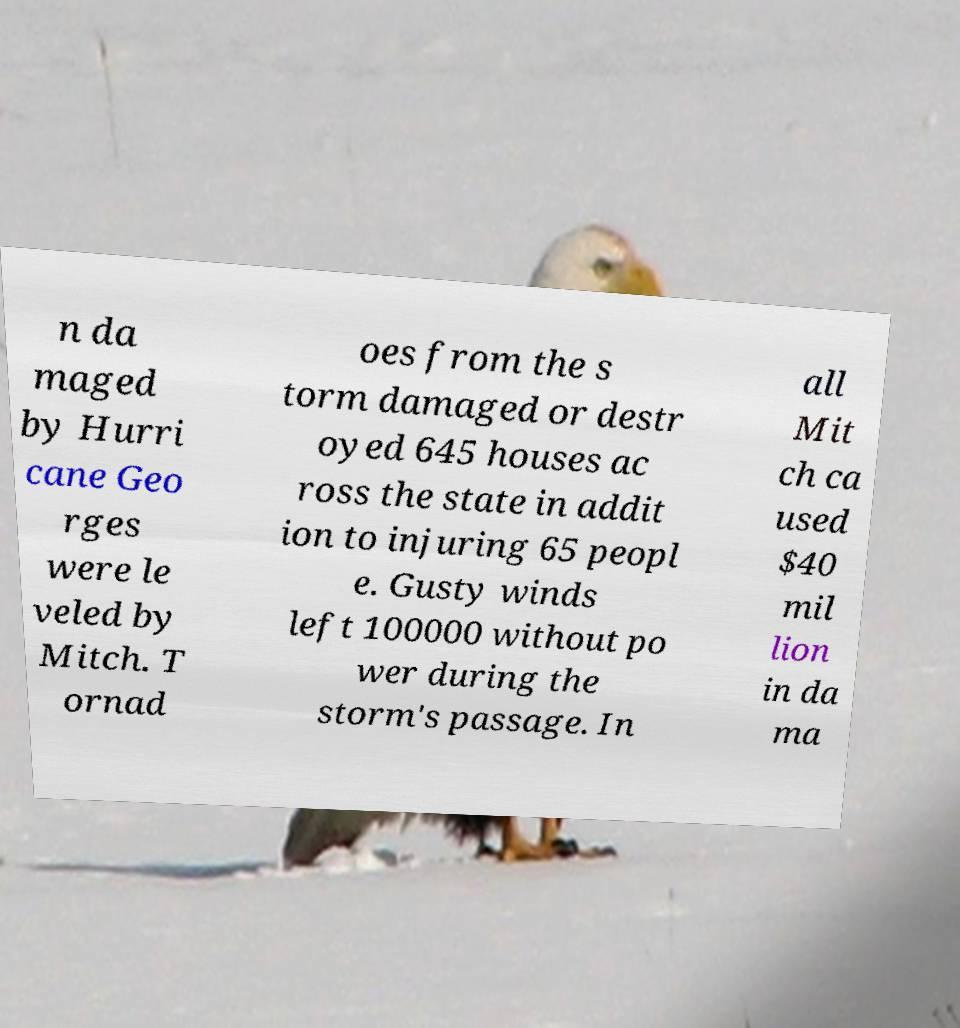I need the written content from this picture converted into text. Can you do that? n da maged by Hurri cane Geo rges were le veled by Mitch. T ornad oes from the s torm damaged or destr oyed 645 houses ac ross the state in addit ion to injuring 65 peopl e. Gusty winds left 100000 without po wer during the storm's passage. In all Mit ch ca used $40 mil lion in da ma 